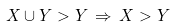<formula> <loc_0><loc_0><loc_500><loc_500>X \cup Y > Y \, \Rightarrow \, X > Y</formula> 